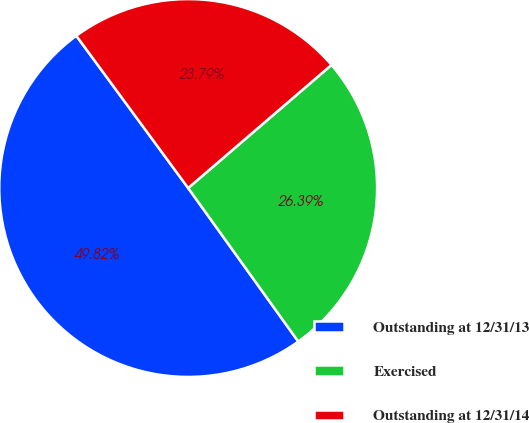Convert chart. <chart><loc_0><loc_0><loc_500><loc_500><pie_chart><fcel>Outstanding at 12/31/13<fcel>Exercised<fcel>Outstanding at 12/31/14<nl><fcel>49.82%<fcel>26.39%<fcel>23.79%<nl></chart> 